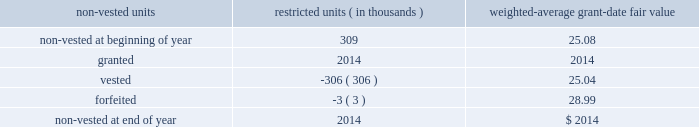Restricted unit awards in 2010 and 2009 , the hartford issued restricted units as part of the hartford 2019s 2005 stock plan .
Restricted stock unit awards under the plan have historically been settled in shares , but under this award will be settled in cash and are thus referred to as 201crestricted units 201d .
The economic value recipients will ultimately realize will be identical to the value that would have been realized if the awards had been settled in shares , i.e. , upon settlement , recipients will receive cash equal to the hartford 2019s share price multiplied by the number of restricted units awarded .
Because restricted units will be settled in cash , the awards are remeasured at the end of each reporting period until settlement .
Awards granted in 2009 vested after a three year period .
Awards granted in 2010 include both graded and cliff vesting restricted units which vest over a three year period .
The graded vesting attribution method is used to recognize the expense of the award over the requisite service period .
For example , the graded vesting attribution method views one three-year grant with annual graded vesting as three separate sub-grants , each representing one third of the total number of awards granted .
The first sub-grant vests over one year , the second sub-grant vests over two years and the third sub-grant vests over three years .
There were no restricted units awarded for 2013 or 2012 .
As of december 31 , 2013 and 2012 , 27 thousand and 832 thousand restricted units were outstanding , respectively .
Deferred stock unit plan effective july 31 , 2009 , the compensation and management development committee of the board authorized the hartford deferred stock unit plan ( 201cdeferred stock unit plan 201d ) , and , on october 22 , 2009 , it was amended .
The deferred stock unit plan provides for contractual rights to receive cash payments based on the value of a specified number of shares of stock .
The deferred stock unit plan provides for two award types , deferred units and restricted units .
Deferred units are earned ratably over a year , based on the number of regular pay periods occurring during such year .
Deferred units are credited to the participant's account on a quarterly basis based on the market price of the company 2019s common stock on the date of grant and are fully vested at all times .
Deferred units credited to employees prior to january 1 , 2010 ( other than senior executive officers hired on or after october 1 , 2009 ) are not paid until after two years from their grant date .
Deferred units credited on or after january 1 , 2010 ( and any credited to senior executive officers hired on or after october 1 , 2009 ) are paid in three equal installments after the first , second and third anniversaries of their grant date .
Restricted units are intended to be incentive compensation and , unlike deferred units , vest over time , generally three years , and are subject to forfeiture .
The deferred stock unit plan is structured consistent with the limitations and restrictions on employee compensation arrangements imposed by the emergency economic stabilization act of 2008 and the tarp standards for compensation and corporate governance interim final rule issued by the u.s .
Department of treasury on june 10 , 2009 .
There were no deferred stock units awarded in 2013 or 2012 .
A summary of the status of the company 2019s non-vested awards under the deferred stock unit plan as of december 31 , 2013 , is presented below : non-vested units restricted units ( in thousands ) weighted-average grant-date fair value .
Subsidiary stock plan in 2013 the hartford established a subsidiary stock-based compensation plan similar to the hartford 2010 incentive stock plan except that it awards non-public subsidiary stock as compensation .
The company recognized stock-based compensation plans expense of $ 1 in the year ended december 31 , 2013 for the subsidiary stock plan .
Upon employee vesting of subsidiary stock , the company will recognize a noncontrolling equity interest .
Employees will be restricted from selling vested subsidiary stock to other than the company and the company will have discretion on the amount of stock to repurchase .
Therefore the subsidiary stock will be classified as equity because it is not mandatorily redeemable .
Table of contents the hartford financial services group , inc .
Notes to consolidated financial statements ( continued ) 19 .
Stock compensation plans ( continued ) .
What is the total value of the forfeited units? 
Computations: (3 * 28.99)
Answer: 86.97. Restricted unit awards in 2010 and 2009 , the hartford issued restricted units as part of the hartford 2019s 2005 stock plan .
Restricted stock unit awards under the plan have historically been settled in shares , but under this award will be settled in cash and are thus referred to as 201crestricted units 201d .
The economic value recipients will ultimately realize will be identical to the value that would have been realized if the awards had been settled in shares , i.e. , upon settlement , recipients will receive cash equal to the hartford 2019s share price multiplied by the number of restricted units awarded .
Because restricted units will be settled in cash , the awards are remeasured at the end of each reporting period until settlement .
Awards granted in 2009 vested after a three year period .
Awards granted in 2010 include both graded and cliff vesting restricted units which vest over a three year period .
The graded vesting attribution method is used to recognize the expense of the award over the requisite service period .
For example , the graded vesting attribution method views one three-year grant with annual graded vesting as three separate sub-grants , each representing one third of the total number of awards granted .
The first sub-grant vests over one year , the second sub-grant vests over two years and the third sub-grant vests over three years .
There were no restricted units awarded for 2013 or 2012 .
As of december 31 , 2013 and 2012 , 27 thousand and 832 thousand restricted units were outstanding , respectively .
Deferred stock unit plan effective july 31 , 2009 , the compensation and management development committee of the board authorized the hartford deferred stock unit plan ( 201cdeferred stock unit plan 201d ) , and , on october 22 , 2009 , it was amended .
The deferred stock unit plan provides for contractual rights to receive cash payments based on the value of a specified number of shares of stock .
The deferred stock unit plan provides for two award types , deferred units and restricted units .
Deferred units are earned ratably over a year , based on the number of regular pay periods occurring during such year .
Deferred units are credited to the participant's account on a quarterly basis based on the market price of the company 2019s common stock on the date of grant and are fully vested at all times .
Deferred units credited to employees prior to january 1 , 2010 ( other than senior executive officers hired on or after october 1 , 2009 ) are not paid until after two years from their grant date .
Deferred units credited on or after january 1 , 2010 ( and any credited to senior executive officers hired on or after october 1 , 2009 ) are paid in three equal installments after the first , second and third anniversaries of their grant date .
Restricted units are intended to be incentive compensation and , unlike deferred units , vest over time , generally three years , and are subject to forfeiture .
The deferred stock unit plan is structured consistent with the limitations and restrictions on employee compensation arrangements imposed by the emergency economic stabilization act of 2008 and the tarp standards for compensation and corporate governance interim final rule issued by the u.s .
Department of treasury on june 10 , 2009 .
There were no deferred stock units awarded in 2013 or 2012 .
A summary of the status of the company 2019s non-vested awards under the deferred stock unit plan as of december 31 , 2013 , is presented below : non-vested units restricted units ( in thousands ) weighted-average grant-date fair value .
Subsidiary stock plan in 2013 the hartford established a subsidiary stock-based compensation plan similar to the hartford 2010 incentive stock plan except that it awards non-public subsidiary stock as compensation .
The company recognized stock-based compensation plans expense of $ 1 in the year ended december 31 , 2013 for the subsidiary stock plan .
Upon employee vesting of subsidiary stock , the company will recognize a noncontrolling equity interest .
Employees will be restricted from selling vested subsidiary stock to other than the company and the company will have discretion on the amount of stock to repurchase .
Therefore the subsidiary stock will be classified as equity because it is not mandatorily redeemable .
Table of contents the hartford financial services group , inc .
Notes to consolidated financial statements ( continued ) 19 .
Stock compensation plans ( continued ) .
What is the total value of the vested units? 
Computations: (306 * 25.04)
Answer: 7662.24. 